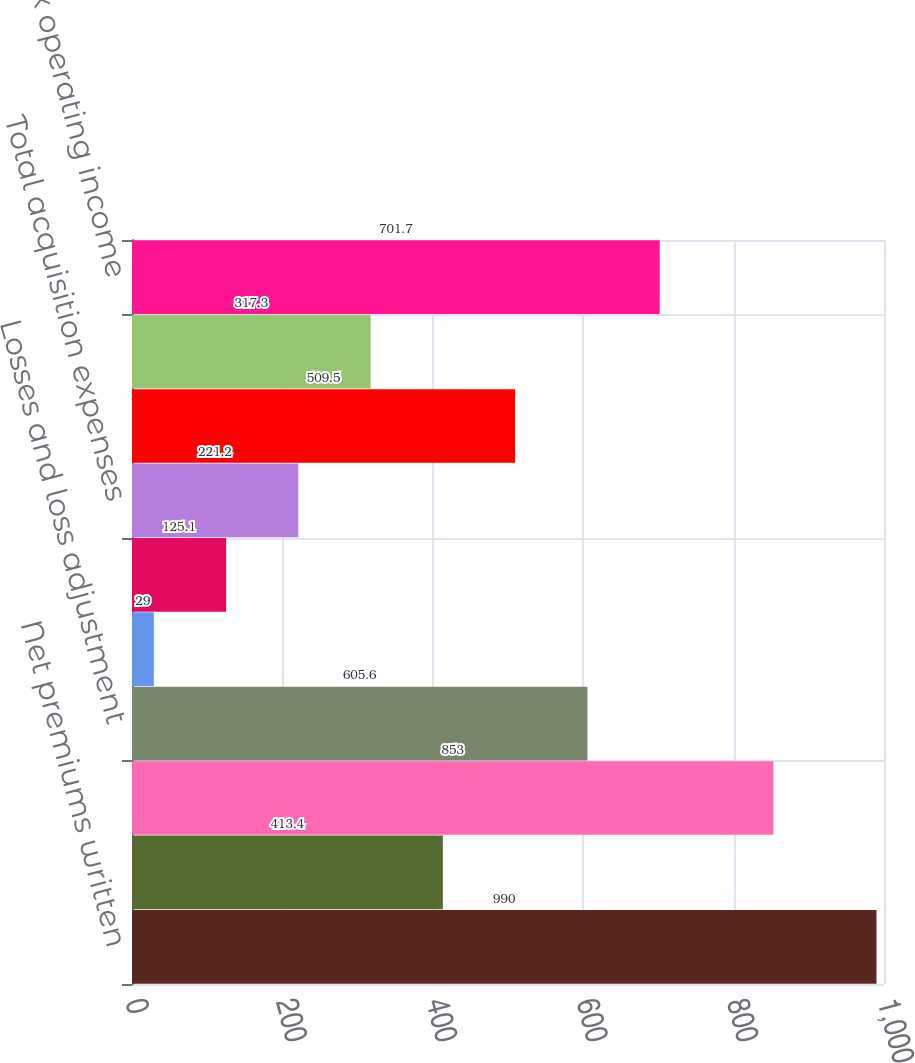Convert chart. <chart><loc_0><loc_0><loc_500><loc_500><bar_chart><fcel>Net premiums written<fcel>Increase in unearned premiums<fcel>Net premiums earned<fcel>Losses and loss adjustment<fcel>Amortization of deferred<fcel>Other acquisition expenses<fcel>Total acquisition expenses<fcel>General operating expenses<fcel>Net investment income<fcel>Pre-tax operating income<nl><fcel>990<fcel>413.4<fcel>853<fcel>605.6<fcel>29<fcel>125.1<fcel>221.2<fcel>509.5<fcel>317.3<fcel>701.7<nl></chart> 